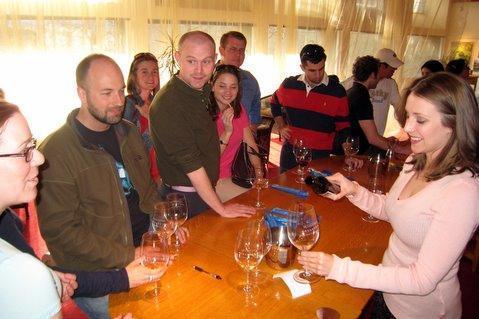How many people are there?
Give a very brief answer. 8. How many baby elephants are there?
Give a very brief answer. 0. 